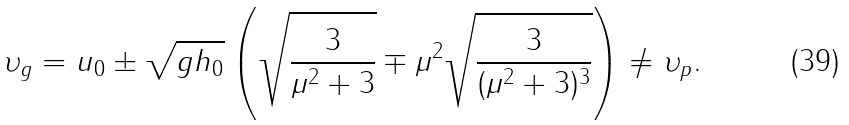Convert formula to latex. <formula><loc_0><loc_0><loc_500><loc_500>\upsilon _ { g } = u _ { 0 } \pm \sqrt { g h _ { 0 } } \left ( \sqrt { \frac { 3 } { \mu ^ { 2 } + 3 } } \mp \mu ^ { 2 } \sqrt { \frac { 3 } { ( \mu ^ { 2 } + 3 ) ^ { 3 } } } \right ) \neq \upsilon _ { p } .</formula> 